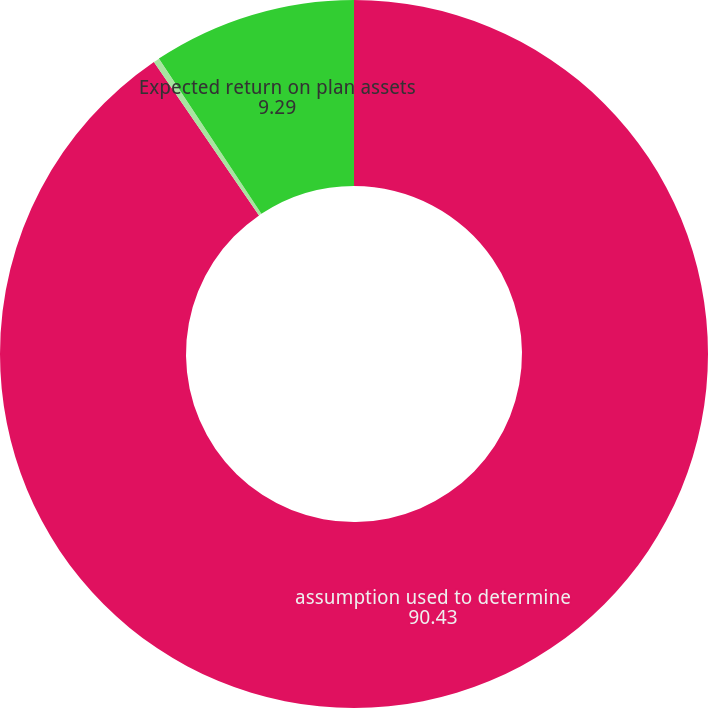<chart> <loc_0><loc_0><loc_500><loc_500><pie_chart><fcel>assumption used to determine<fcel>Discount rate<fcel>Expected return on plan assets<nl><fcel>90.43%<fcel>0.27%<fcel>9.29%<nl></chart> 